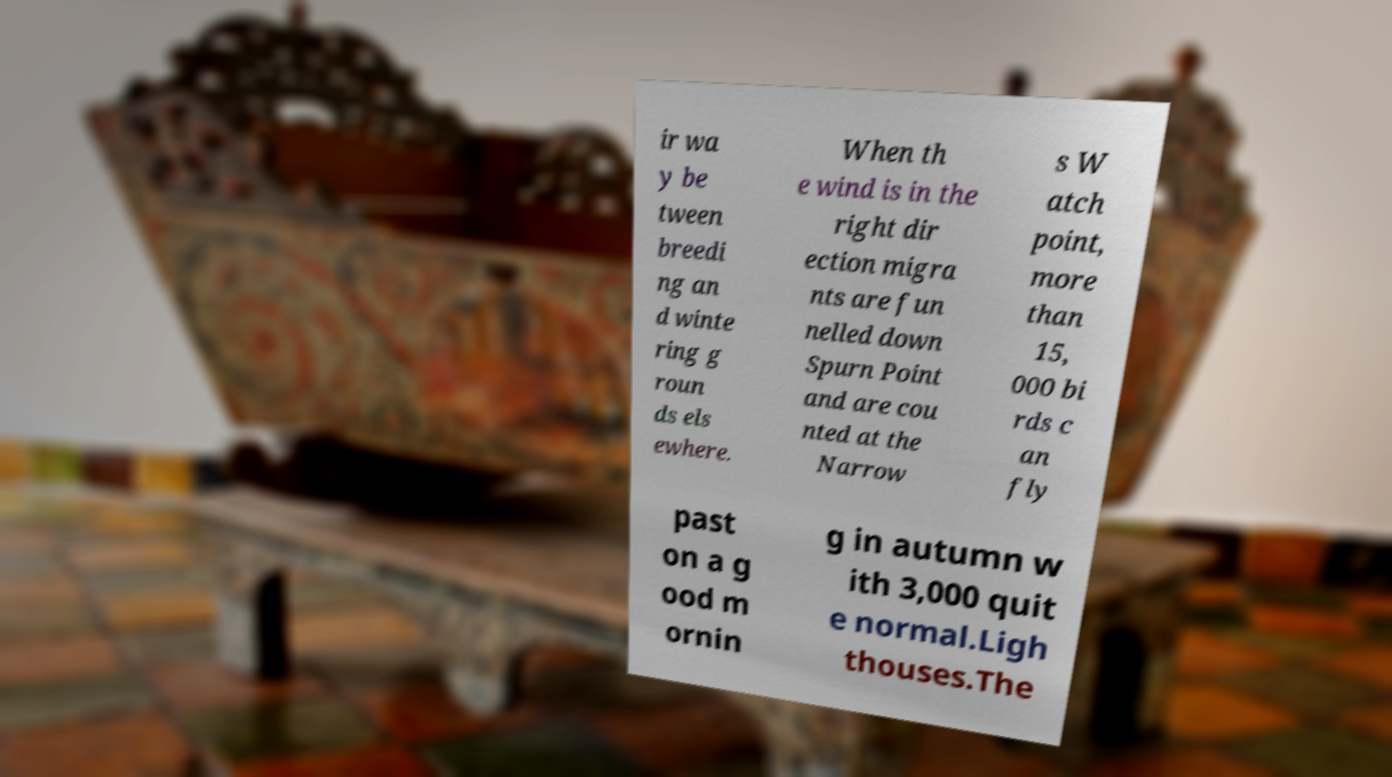What messages or text are displayed in this image? I need them in a readable, typed format. ir wa y be tween breedi ng an d winte ring g roun ds els ewhere. When th e wind is in the right dir ection migra nts are fun nelled down Spurn Point and are cou nted at the Narrow s W atch point, more than 15, 000 bi rds c an fly past on a g ood m ornin g in autumn w ith 3,000 quit e normal.Ligh thouses.The 